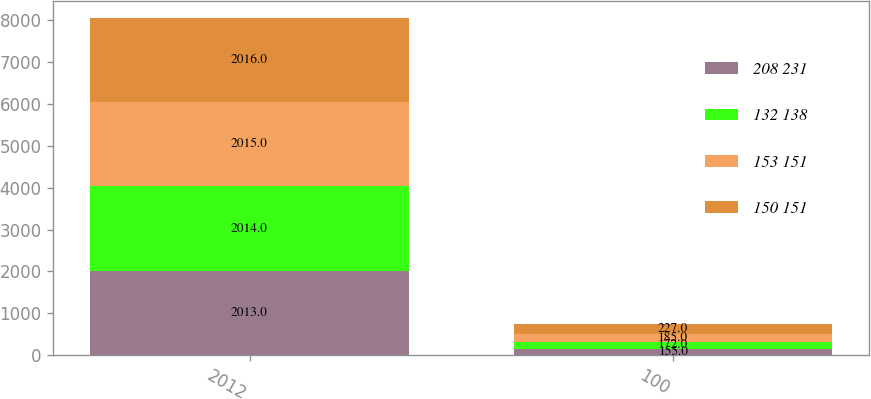<chart> <loc_0><loc_0><loc_500><loc_500><stacked_bar_chart><ecel><fcel>2012<fcel>100<nl><fcel>208 231<fcel>2013<fcel>155<nl><fcel>132 138<fcel>2014<fcel>172<nl><fcel>153 151<fcel>2015<fcel>185<nl><fcel>150 151<fcel>2016<fcel>227<nl></chart> 